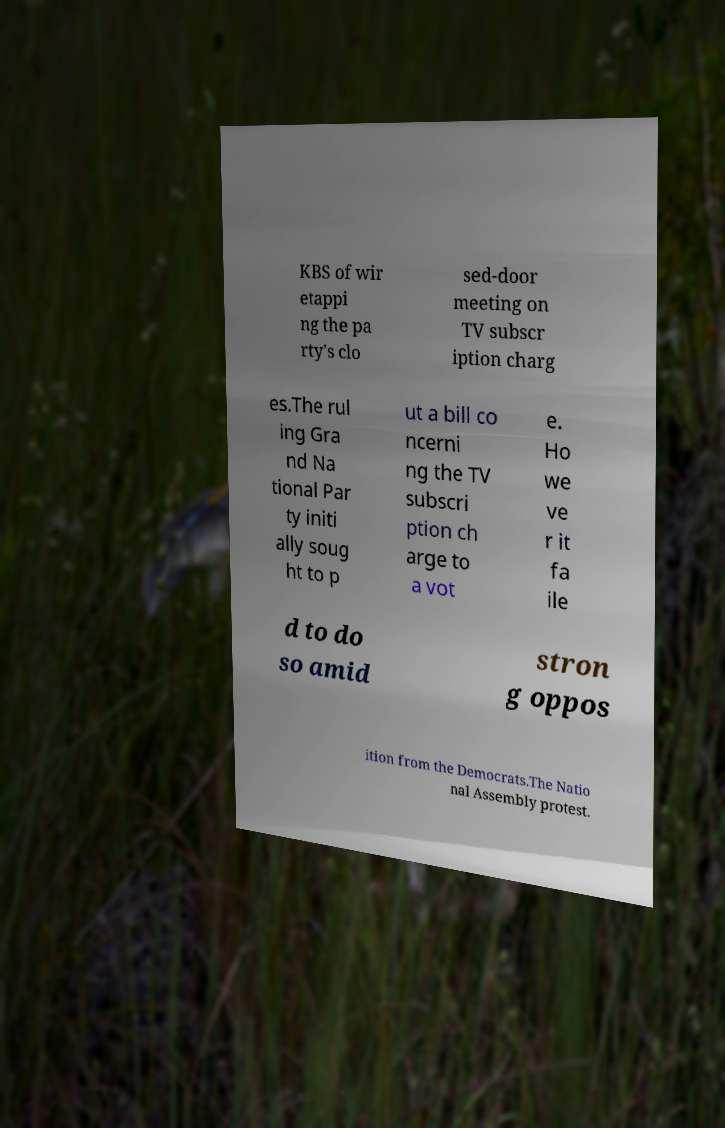There's text embedded in this image that I need extracted. Can you transcribe it verbatim? KBS of wir etappi ng the pa rty's clo sed-door meeting on TV subscr iption charg es.The rul ing Gra nd Na tional Par ty initi ally soug ht to p ut a bill co ncerni ng the TV subscri ption ch arge to a vot e. Ho we ve r it fa ile d to do so amid stron g oppos ition from the Democrats.The Natio nal Assembly protest. 